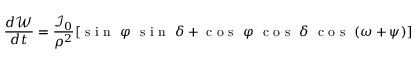<formula> <loc_0><loc_0><loc_500><loc_500>\frac { d \mathcal { W } } { d t } = \frac { \mathcal { I } _ { 0 } } { \rho ^ { 2 } } [ \sin \ \varphi \ \sin \ \delta + \cos \ \varphi \ \cos \ \delta \ \cos \ ( \omega + \psi ) ]</formula> 